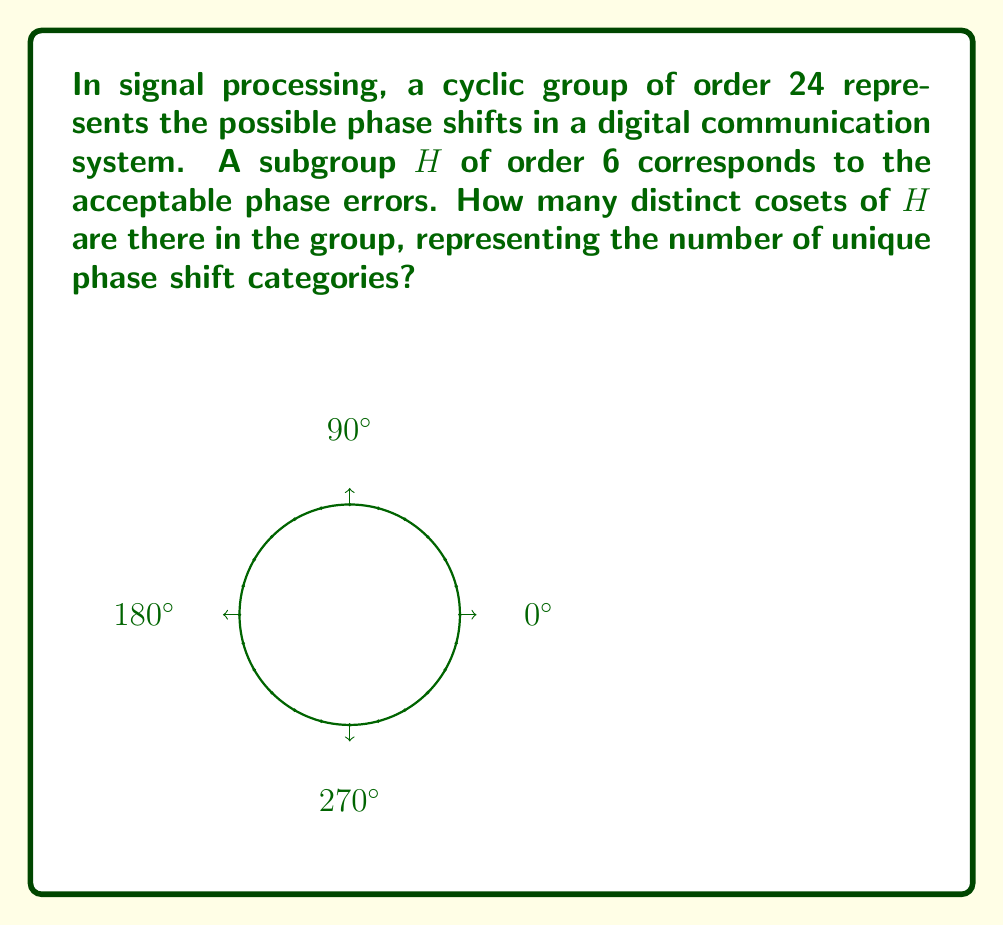Could you help me with this problem? Let's approach this step-by-step:

1) We are dealing with a group G of order 24 and a subgroup H of order 6.

2) To find the number of cosets, we can use Lagrange's theorem, which states that for a finite group G and a subgroup H of G:

   $$ |G| = |H| \cdot [G:H] $$

   where |G| is the order of G, |H| is the order of H, and [G:H] is the index of H in G (which is equal to the number of cosets).

3) We know:
   $$ |G| = 24 $$
   $$ |H| = 6 $$

4) Substituting these into Lagrange's theorem:

   $$ 24 = 6 \cdot [G:H] $$

5) Solving for [G:H]:

   $$ [G:H] = \frac{24}{6} = 4 $$

6) Therefore, there are 4 distinct cosets of H in G.

In the context of signal processing, this means there are 4 unique categories of phase shifts when considering the acceptable phase errors.
Answer: 4 cosets 